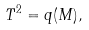Convert formula to latex. <formula><loc_0><loc_0><loc_500><loc_500>\, T ^ { 2 } = q ( M ) ,</formula> 